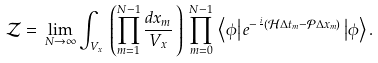<formula> <loc_0><loc_0><loc_500><loc_500>\mathcal { Z } = \, \lim _ { N \rightarrow \infty } \int _ { V _ { x } } \, \left ( \prod _ { m = 1 } ^ { N - 1 } \frac { d x _ { m } } { V _ { x } } \, \right ) \, \prod _ { m = 0 } ^ { N - 1 } \, \left \langle \phi \right | e ^ { - \frac { i } { } ( \mathcal { H } \Delta t _ { m } - \mathcal { P } \Delta x _ { m } ) } \left | \phi \right \rangle .</formula> 